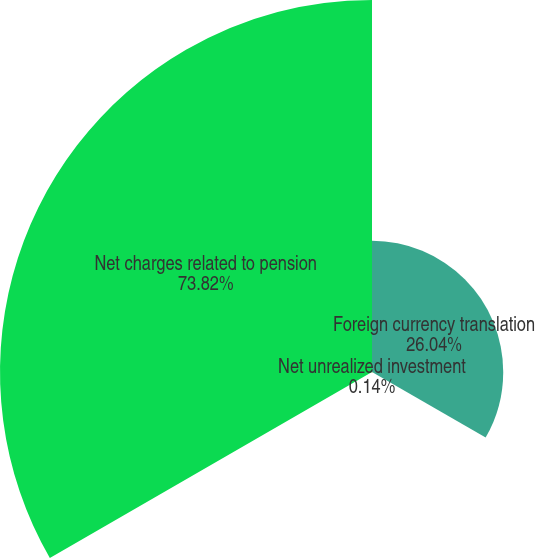Convert chart. <chart><loc_0><loc_0><loc_500><loc_500><pie_chart><fcel>Foreign currency translation<fcel>Net unrealized investment<fcel>Net charges related to pension<nl><fcel>26.04%<fcel>0.14%<fcel>73.82%<nl></chart> 